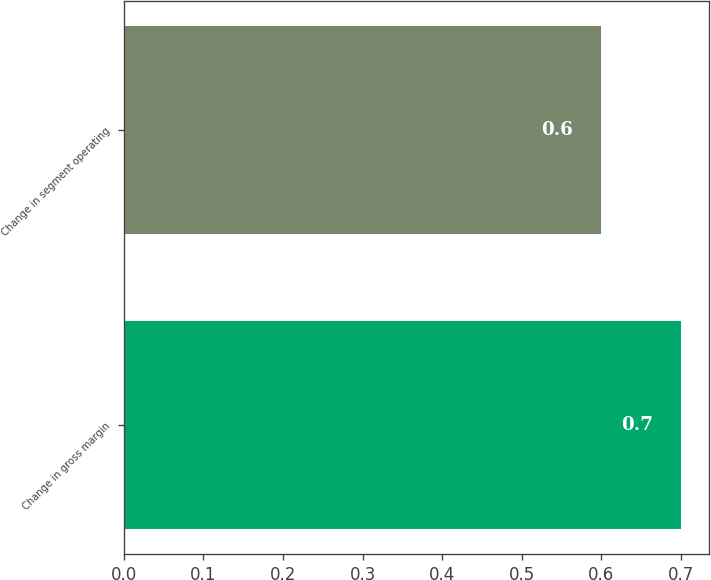Convert chart. <chart><loc_0><loc_0><loc_500><loc_500><bar_chart><fcel>Change in gross margin<fcel>Change in segment operating<nl><fcel>0.7<fcel>0.6<nl></chart> 